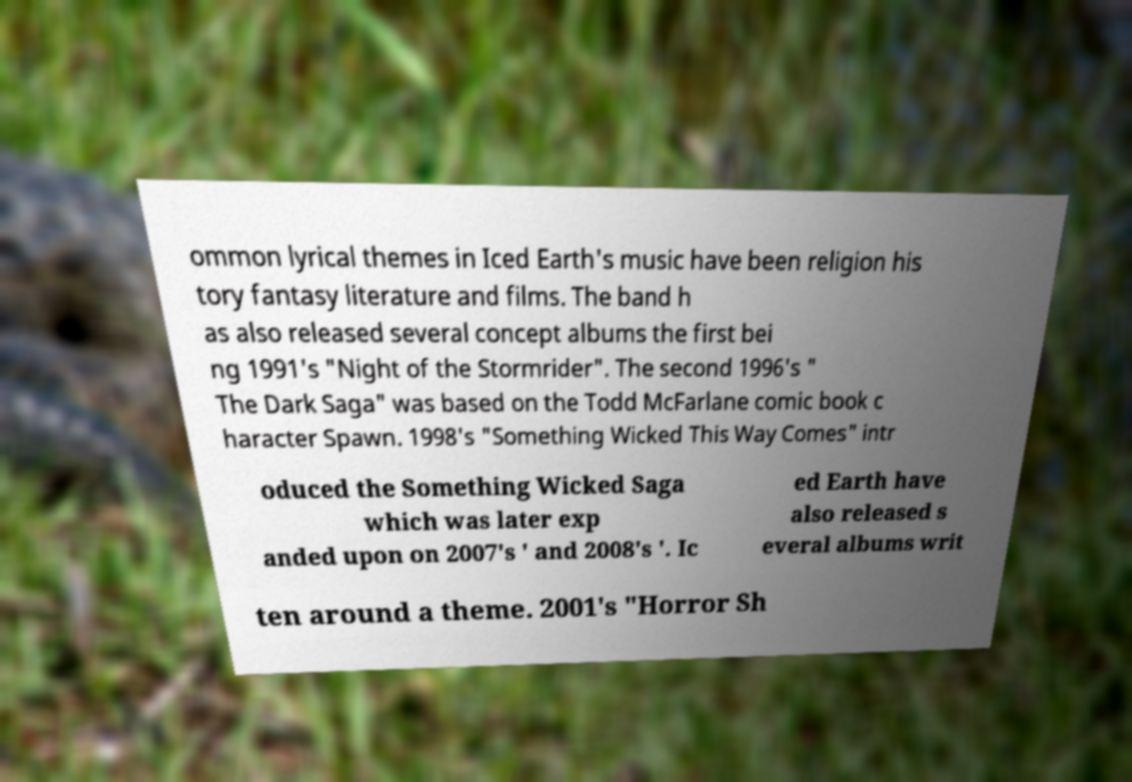What messages or text are displayed in this image? I need them in a readable, typed format. ommon lyrical themes in Iced Earth's music have been religion his tory fantasy literature and films. The band h as also released several concept albums the first bei ng 1991's "Night of the Stormrider". The second 1996's " The Dark Saga" was based on the Todd McFarlane comic book c haracter Spawn. 1998's "Something Wicked This Way Comes" intr oduced the Something Wicked Saga which was later exp anded upon on 2007's ' and 2008's '. Ic ed Earth have also released s everal albums writ ten around a theme. 2001's "Horror Sh 